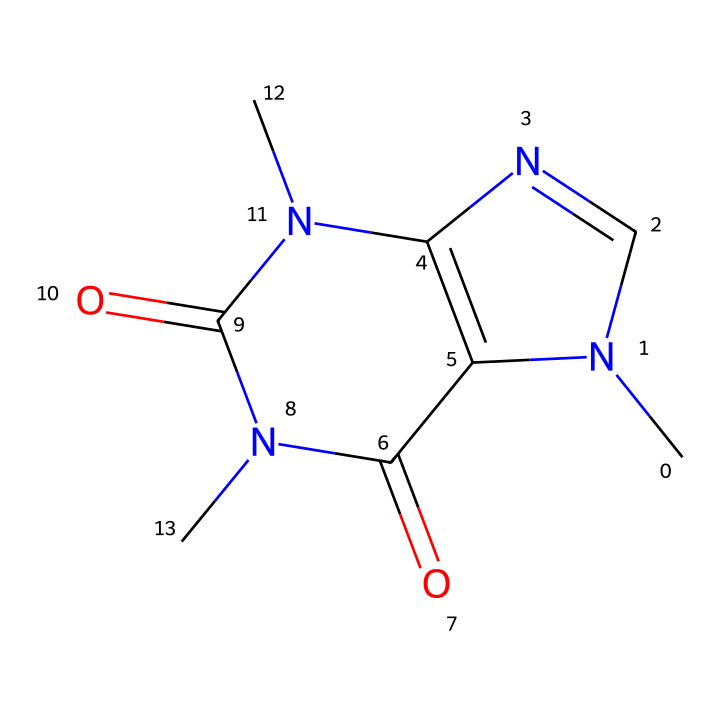What is the total number of nitrogen atoms in this caffeine structure? The SMILES representation indicates the presence of nitrogen atoms (N). By counting the occurrences of 'N' in the formula, we find there are two nitrogen atoms present in the structure.
Answer: 2 What is the key functional group present in caffeine? The structure contains amide groups (−C(=O)N−) as seen in the SMILES representation where 'C(=O)N' forms part of the chemical. This indicates the presence of a carbonyl attached to a nitrogen.
Answer: amide How many carbon atoms are there in the caffeine structure? The total number of carbon atoms can be counted directly from the SMILES representation. Each 'C' indicates a carbon atom, and by counting them, we find there are eight carbon atoms in the structure.
Answer: 8 Which atoms in the structure contribute to the drug's stimulant properties? The nitrogen atoms in the caffeine structure, particularly those in the amine groups, are critical for stimulating effects, as they interact with adenosine receptors in the brain.
Answer: nitrogen What type of compound is caffeine classified as? Based on its structure, which features multiple nitrogen atoms and a complex arrangement, caffeine is classified as an alkaloid—substances derived from plants that often have pharmacological effects.
Answer: alkaloid Do the carbon atoms in caffeine form a ring structure? Looking at the SMILES representation, the carbon atoms form a bicyclic structure, indicating that at least some of the carbon atoms are part of a cyclic structure, typical of many alkaloids, including caffeine.
Answer: yes 